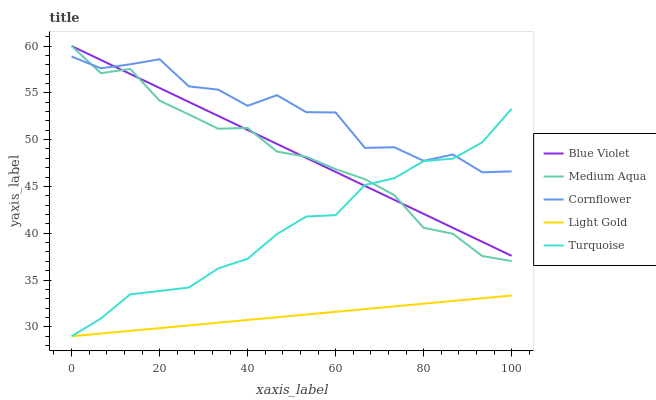Does Light Gold have the minimum area under the curve?
Answer yes or no. Yes. Does Cornflower have the maximum area under the curve?
Answer yes or no. Yes. Does Turquoise have the minimum area under the curve?
Answer yes or no. No. Does Turquoise have the maximum area under the curve?
Answer yes or no. No. Is Light Gold the smoothest?
Answer yes or no. Yes. Is Cornflower the roughest?
Answer yes or no. Yes. Is Turquoise the smoothest?
Answer yes or no. No. Is Turquoise the roughest?
Answer yes or no. No. Does Turquoise have the lowest value?
Answer yes or no. Yes. Does Medium Aqua have the lowest value?
Answer yes or no. No. Does Blue Violet have the highest value?
Answer yes or no. Yes. Does Turquoise have the highest value?
Answer yes or no. No. Is Light Gold less than Blue Violet?
Answer yes or no. Yes. Is Blue Violet greater than Light Gold?
Answer yes or no. Yes. Does Light Gold intersect Turquoise?
Answer yes or no. Yes. Is Light Gold less than Turquoise?
Answer yes or no. No. Is Light Gold greater than Turquoise?
Answer yes or no. No. Does Light Gold intersect Blue Violet?
Answer yes or no. No. 